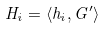<formula> <loc_0><loc_0><loc_500><loc_500>H _ { i } = \langle h _ { i } , G ^ { \prime } \rangle</formula> 